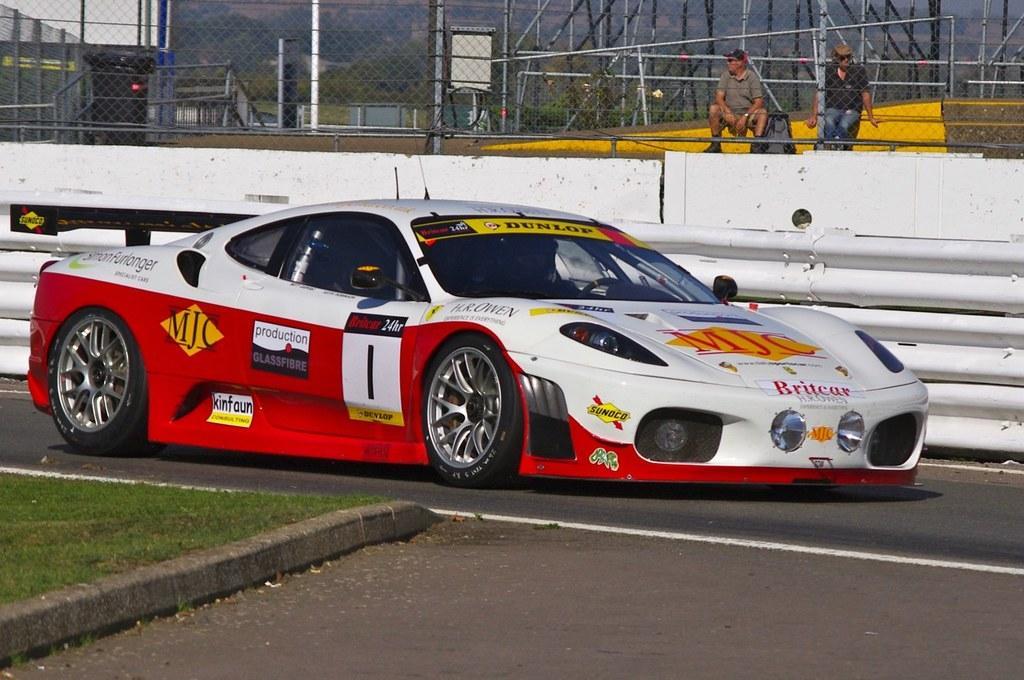Describe this image in one or two sentences. In the foreground the picture there are road, grass and car. In the center of the picture it is well. In the background there are people, fencing and other objects, outside the fencing there are trees. 